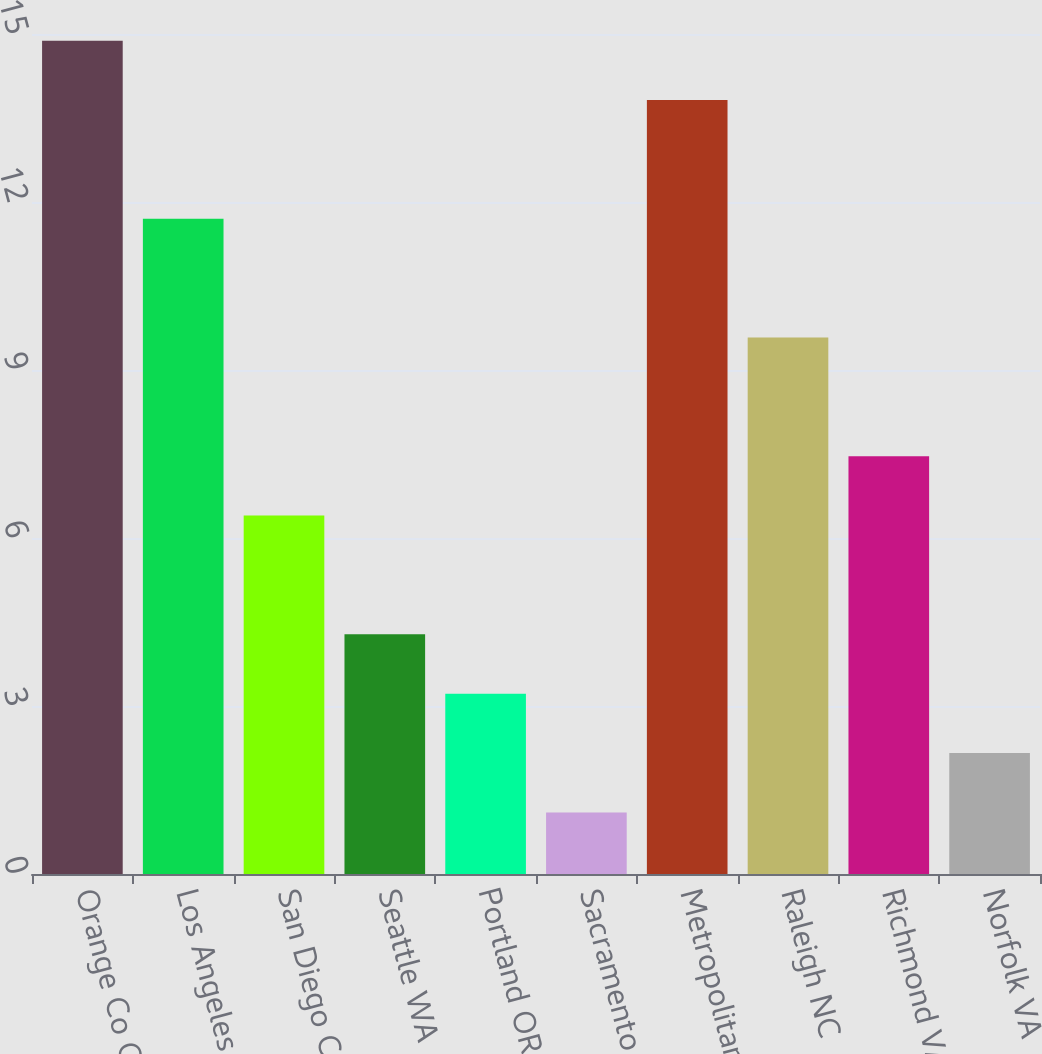<chart> <loc_0><loc_0><loc_500><loc_500><bar_chart><fcel>Orange Co CA<fcel>Los Angeles CA<fcel>San Diego CA<fcel>Seattle WA<fcel>Portland OR<fcel>Sacramento CA<fcel>Metropolitan DC<fcel>Raleigh NC<fcel>Richmond VA<fcel>Norfolk VA<nl><fcel>14.88<fcel>11.7<fcel>6.4<fcel>4.28<fcel>3.22<fcel>1.1<fcel>13.82<fcel>9.58<fcel>7.46<fcel>2.16<nl></chart> 